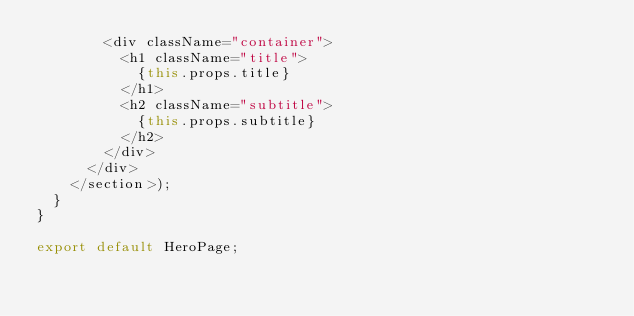<code> <loc_0><loc_0><loc_500><loc_500><_JavaScript_>        <div className="container">
          <h1 className="title">
            {this.props.title}
          </h1>
          <h2 className="subtitle">
            {this.props.subtitle}
          </h2>
        </div>
      </div>
    </section>);
  }
}

export default HeroPage;
</code> 